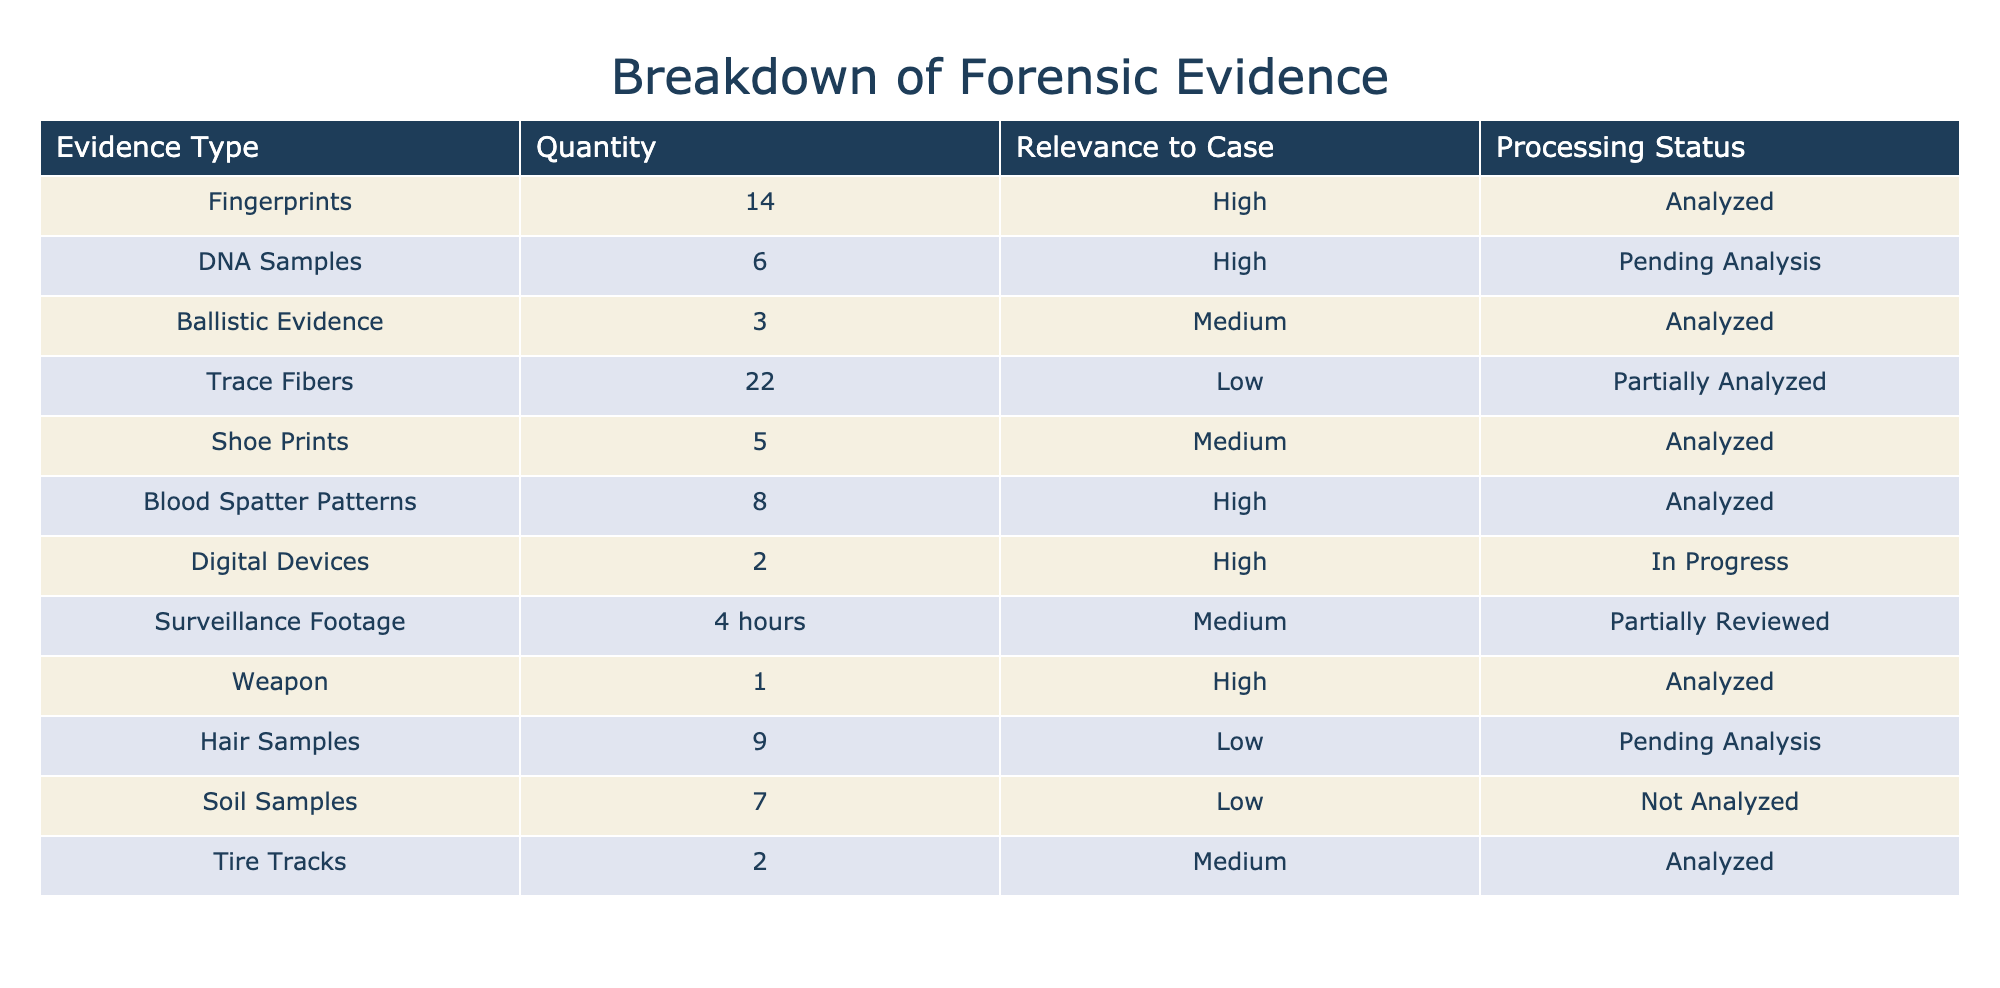What is the total quantity of DNA samples collected? There are 6 DNA samples listed under the "Quantity" column.
Answer: 6 How many types of evidence have been analyzed so far? The types of evidence that have been analyzed are: fingerprints, ballistic evidence, blood spatter patterns, shoe prints, tire tracks, and the weapon, totaling 6 types of analyzed evidence.
Answer: 6 What is the status of the digital devices collected as evidence? The status of the digital devices is "In Progress," indicating they are currently being processed.
Answer: In Progress Are any blood spatter patterns pending analysis? No, the blood spatter patterns are not pending analysis; they have already been analyzed.
Answer: No Which type of evidence has the highest quantity? The evidence type with the highest quantity is trace fibers, with a total of 22 collected.
Answer: Trace Fibers What is the average quantity of medium relevance evidence? The medium relevance evidence includes 3 ballistic evidence, 5 shoe prints, and 2 tire tracks. The total quantity is 3 + 5 + 2 = 10, and the average is 10 / 3 = 3.33.
Answer: 3.33 How many pieces of low relevance evidence are pending analysis? The low relevance evidence includes hair samples and soil samples, with 9 and 7 collected respectively. However, only hair samples are pending analysis, accounting for a total of 9 pieces.
Answer: 9 Is there any type of evidence that has not been analyzed at all? Yes, soil samples have not been analyzed as indicated in the table.
Answer: Yes Which evidence type has the highest relevance and what is its quantity? The evidence types with high relevance include fingerprints (14), DNA samples (6), blood spatter patterns (8), digital devices (2), and the weapon (1). The one with the highest quantity is fingerprints, with 14.
Answer: Fingerprints, 14 